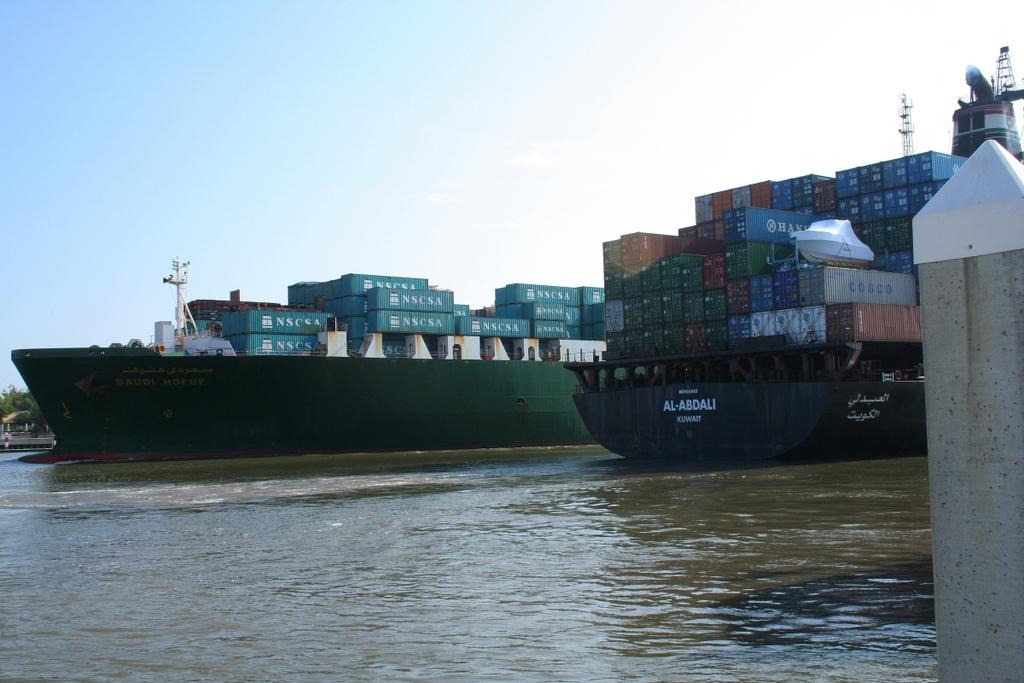<image>
Write a terse but informative summary of the picture. A ship that says Al-Abdali Kuwait is at dock along with another big ship. 